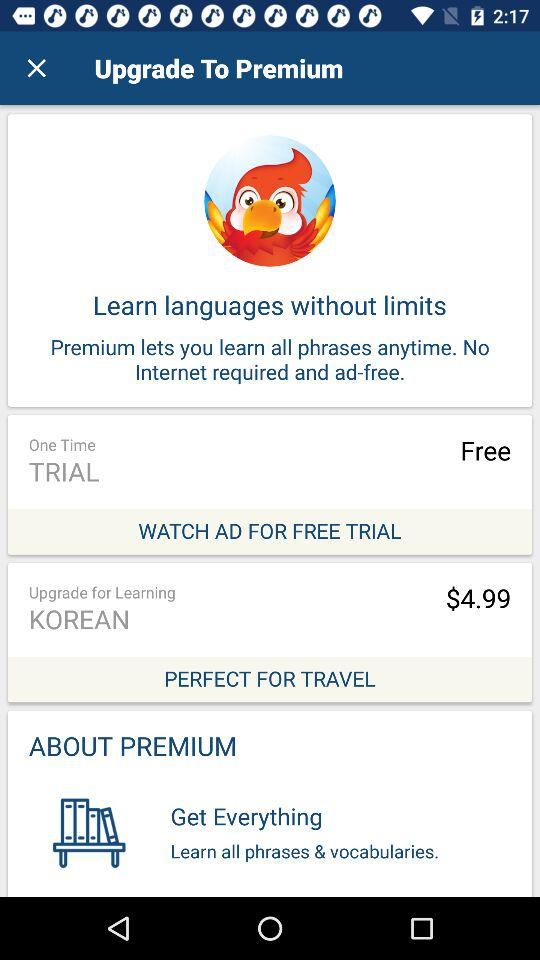How many free trials are there? There is one free trial. 